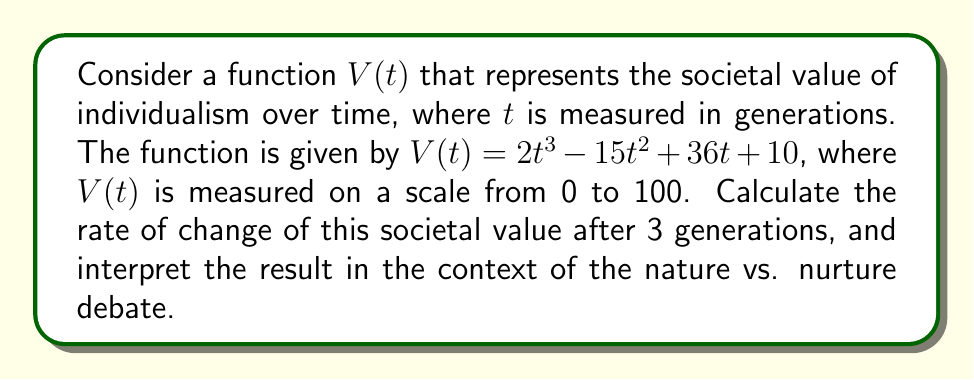Teach me how to tackle this problem. To solve this problem, we need to follow these steps:

1) First, we need to find the derivative of $V(t)$ with respect to $t$. This will give us the rate of change function.

   $V(t) = 2t^3 - 15t^2 + 36t + 10$
   $V'(t) = 6t^2 - 30t + 36$

2) Now that we have the rate of change function, we need to evaluate it at $t = 3$ (after 3 generations).

   $V'(3) = 6(3)^2 - 30(3) + 36$
   $V'(3) = 6(9) - 90 + 36$
   $V'(3) = 54 - 90 + 36$
   $V'(3) = 0$

3) Interpreting the result:
   The rate of change of the societal value of individualism after 3 generations is 0. This means that at this point, the value is neither increasing nor decreasing.

4) In the context of the nature vs. nurture debate:
   This result suggests a balance between genetic inheritance (nature) and environmental factors (nurture) in shaping societal values. After 3 generations, the value of individualism has reached a temporary equilibrium, indicating that the influences of both nature and nurture have momentarily balanced each other out. This aligns with the philosophical view that both factors are equally important in human development.
Answer: $V'(3) = 0$, indicating a momentary equilibrium between nature and nurture influences on individualism after 3 generations. 